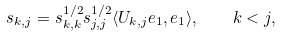Convert formula to latex. <formula><loc_0><loc_0><loc_500><loc_500>s _ { k , j } = s ^ { 1 / 2 } _ { k , k } s ^ { 1 / 2 } _ { j , j } \langle U _ { k , j } e _ { 1 } , e _ { 1 } \rangle , \quad k < j ,</formula> 